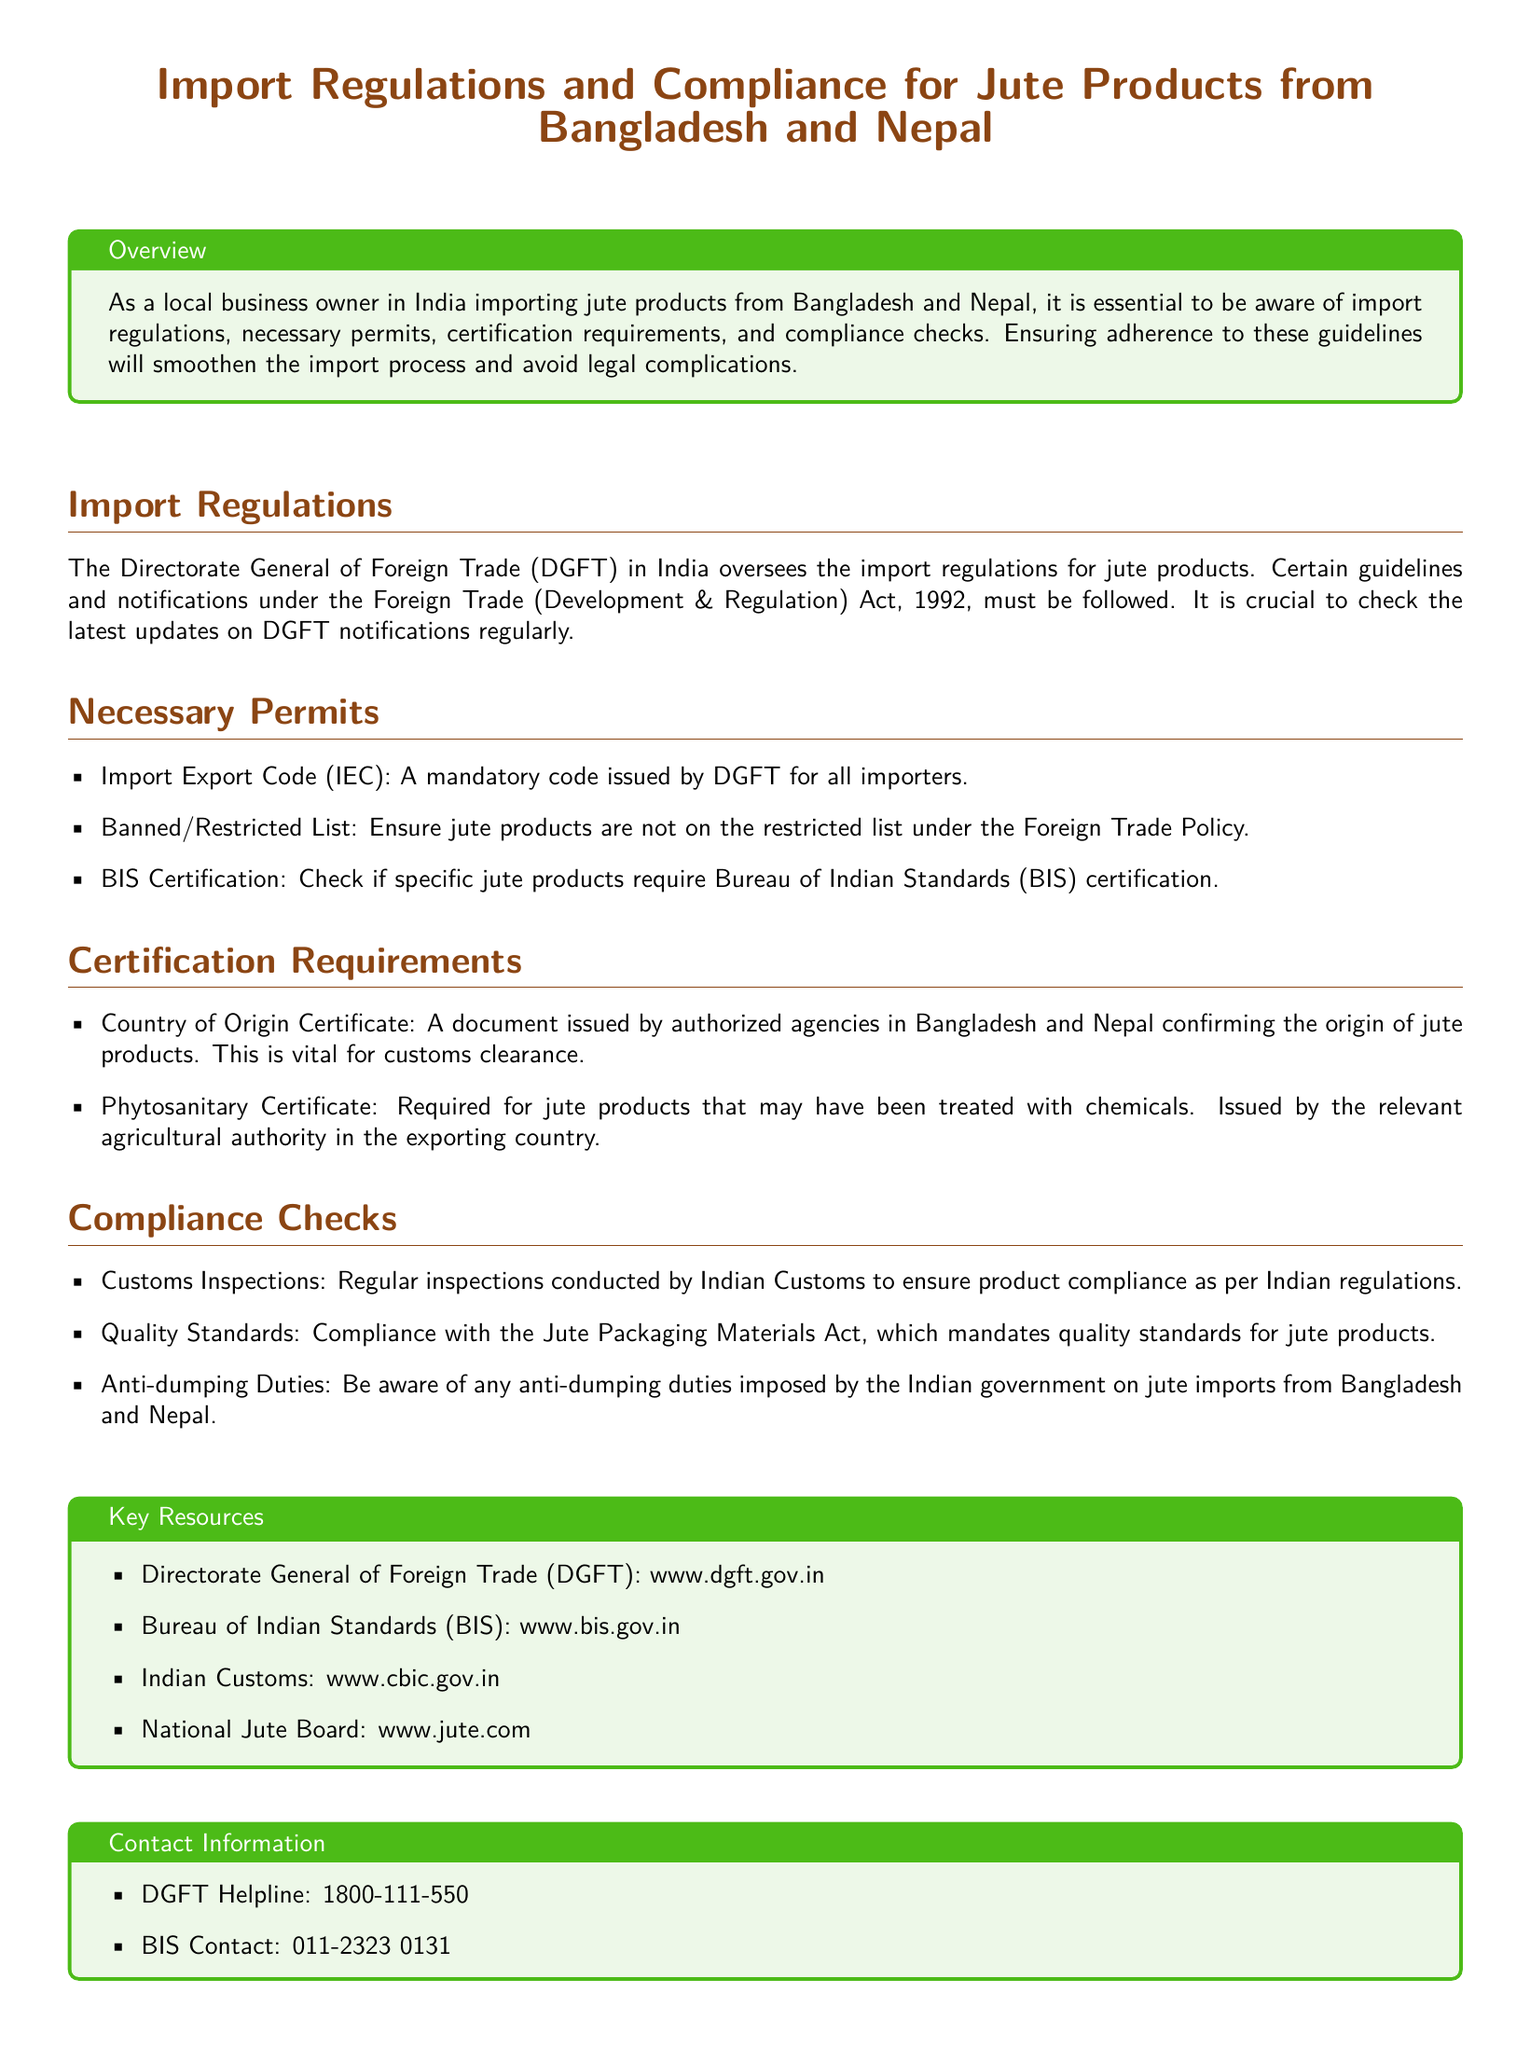What organization oversees import regulations for jute products? The document states that the Directorate General of Foreign Trade (DGFT) oversees import regulations for jute products.
Answer: Directorate General of Foreign Trade (DGFT) What is required for all importers according to the necessary permits? The document mentions that an Import Export Code (IEC) is mandatory for all importers.
Answer: Import Export Code (IEC) Which certification is needed for jute products potentially treated with chemicals? The document specifies that a Phytosanitary Certificate is required for jute products treated with chemicals.
Answer: Phytosanitary Certificate What is the website for the Bureau of Indian Standards? The document provides the website for the Bureau of Indian Standards as www.bis.gov.in.
Answer: www.bis.gov.in What type of duties should importers be aware of regarding jute imports? The document indicates that importers should be aware of anti-dumping duties imposed on jute imports.
Answer: Anti-dumping Duties Which document certifies the origin of jute products? The Country of Origin Certificate is mentioned as certifying the origin of jute products in the document.
Answer: Country of Origin Certificate What acts must the jute products comply with, as stated in the compliance checks? The document mentions the Jute Packaging Materials Act for compliance with quality standards.
Answer: Jute Packaging Materials Act What is the DGFT Helpline number? The document provides the DGFT Helpline number as 1800-111-550.
Answer: 1800-111-550 What should be checked regularly according to the import regulations section? The document indicates that it is crucial to check the latest updates on DGFT notifications regularly.
Answer: Latest updates on DGFT notifications 